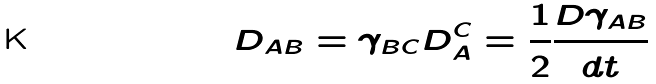<formula> <loc_0><loc_0><loc_500><loc_500>D _ { A B } = \gamma _ { B C } D _ { A } ^ { C } = \frac { 1 } { 2 } \frac { D \gamma _ { A B } } { d t }</formula> 